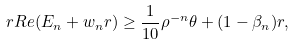Convert formula to latex. <formula><loc_0><loc_0><loc_500><loc_500>\ r R e ( E _ { n } + w _ { n } r ) \geq \frac { 1 } { 1 0 } \rho ^ { - n } \theta + ( 1 - \beta _ { n } ) r ,</formula> 